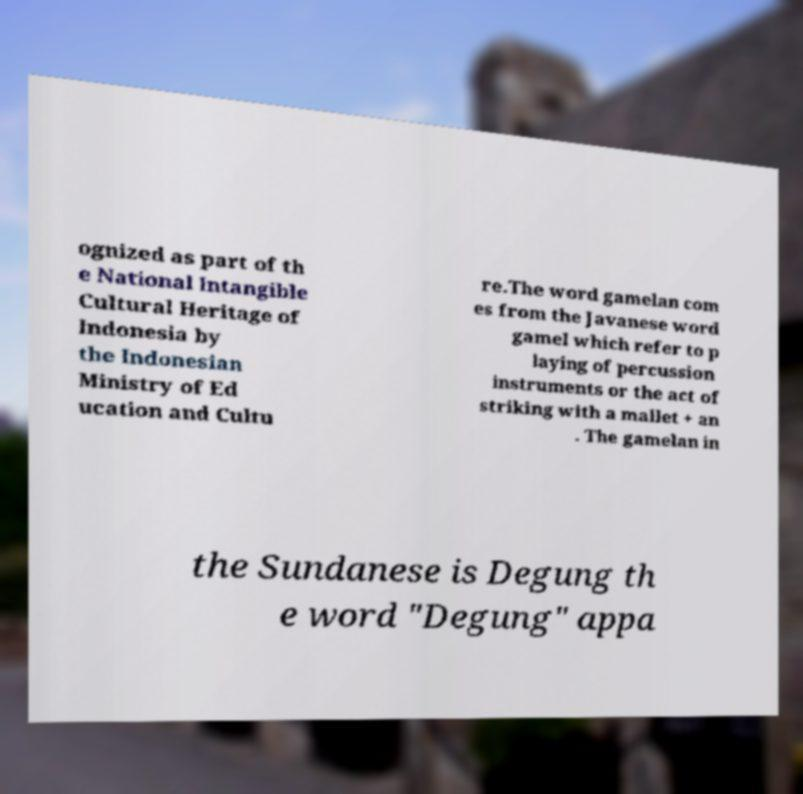Could you assist in decoding the text presented in this image and type it out clearly? ognized as part of th e National Intangible Cultural Heritage of Indonesia by the Indonesian Ministry of Ed ucation and Cultu re.The word gamelan com es from the Javanese word gamel which refer to p laying of percussion instruments or the act of striking with a mallet + an . The gamelan in the Sundanese is Degung th e word "Degung" appa 